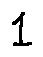<formula> <loc_0><loc_0><loc_500><loc_500>1</formula> 